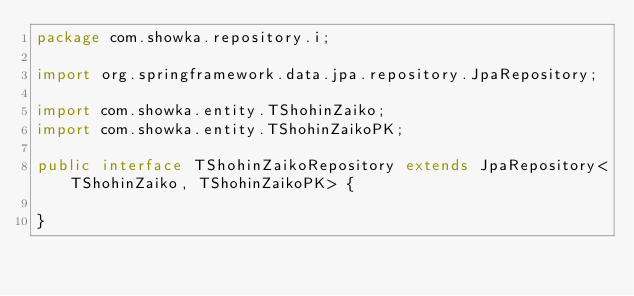<code> <loc_0><loc_0><loc_500><loc_500><_Java_>package com.showka.repository.i;

import org.springframework.data.jpa.repository.JpaRepository;

import com.showka.entity.TShohinZaiko;
import com.showka.entity.TShohinZaikoPK;

public interface TShohinZaikoRepository extends JpaRepository<TShohinZaiko, TShohinZaikoPK> {

}
</code> 